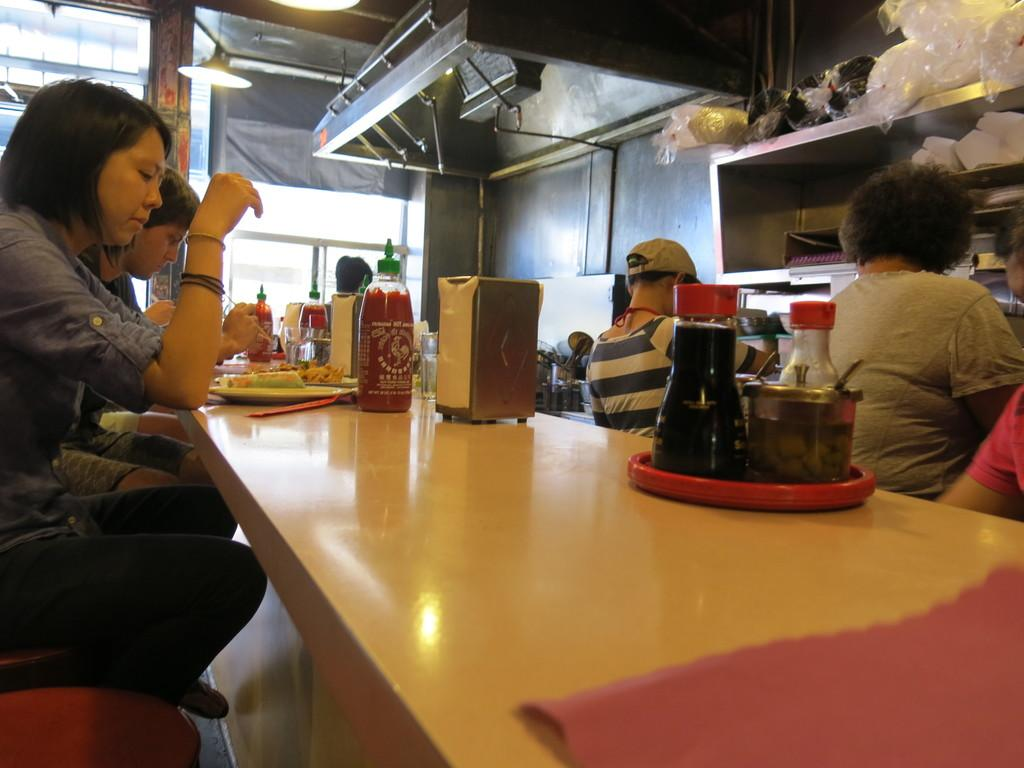What can be seen in the image that provides illumination? There is a light in the image. What are the people in the image doing? The people are sitting on chairs in the image. What is on the table in the image? There is a plate, bottles, and boxes on the table. What is the purpose of the plate on the table? The plate might be used for serving or holding food. What type of food is being served on the map in the image? There is no map present in the image, and therefore no food can be served on it. How long does it take for the minute to pass in the image? The concept of time passing is not visible in the image, so it is not possible to determine how long a minute takes. 